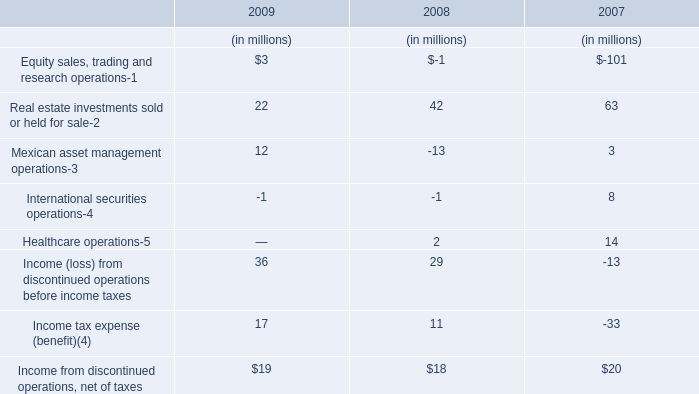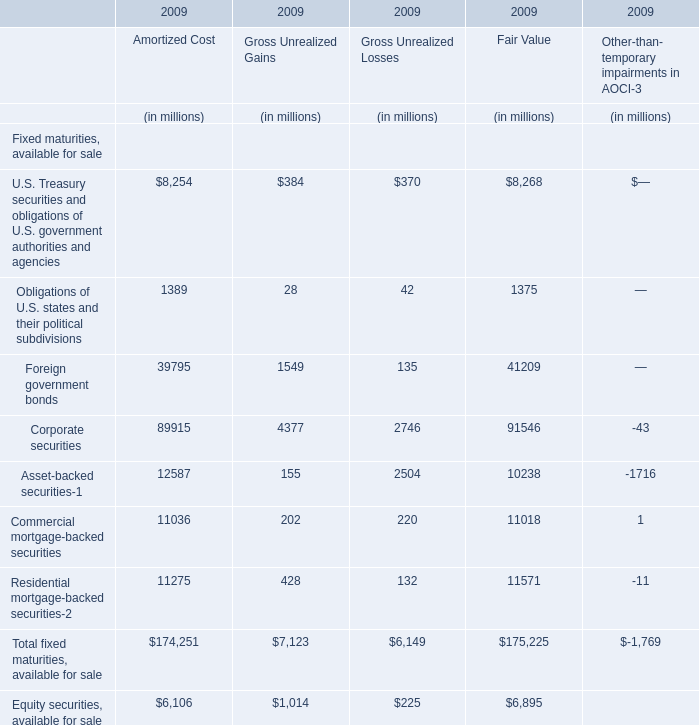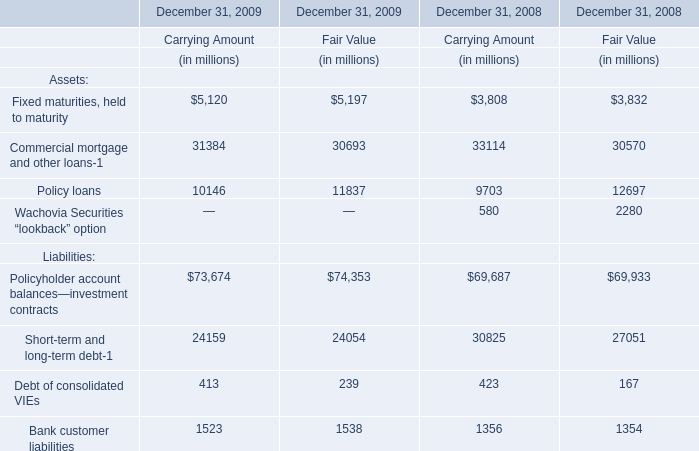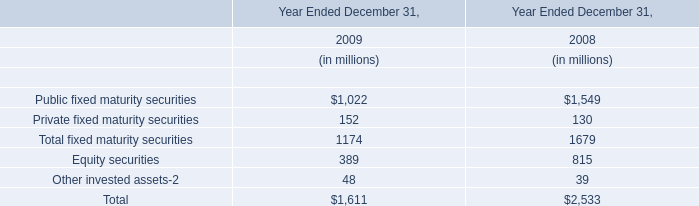As As the chart 1 shows,what's the value of the Gross Unrealized Gains for Total fixed maturities, available for sale in 2009? (in million) 
Answer: 7123. What was the average value of Equity sales, trading and research operations-1, Real estate investments sold or held for sale-2, Mexican asset management operations-3 in 2008? (in million) 
Computations: (((-1 + 42) - 13) / 3)
Answer: 9.33333. 